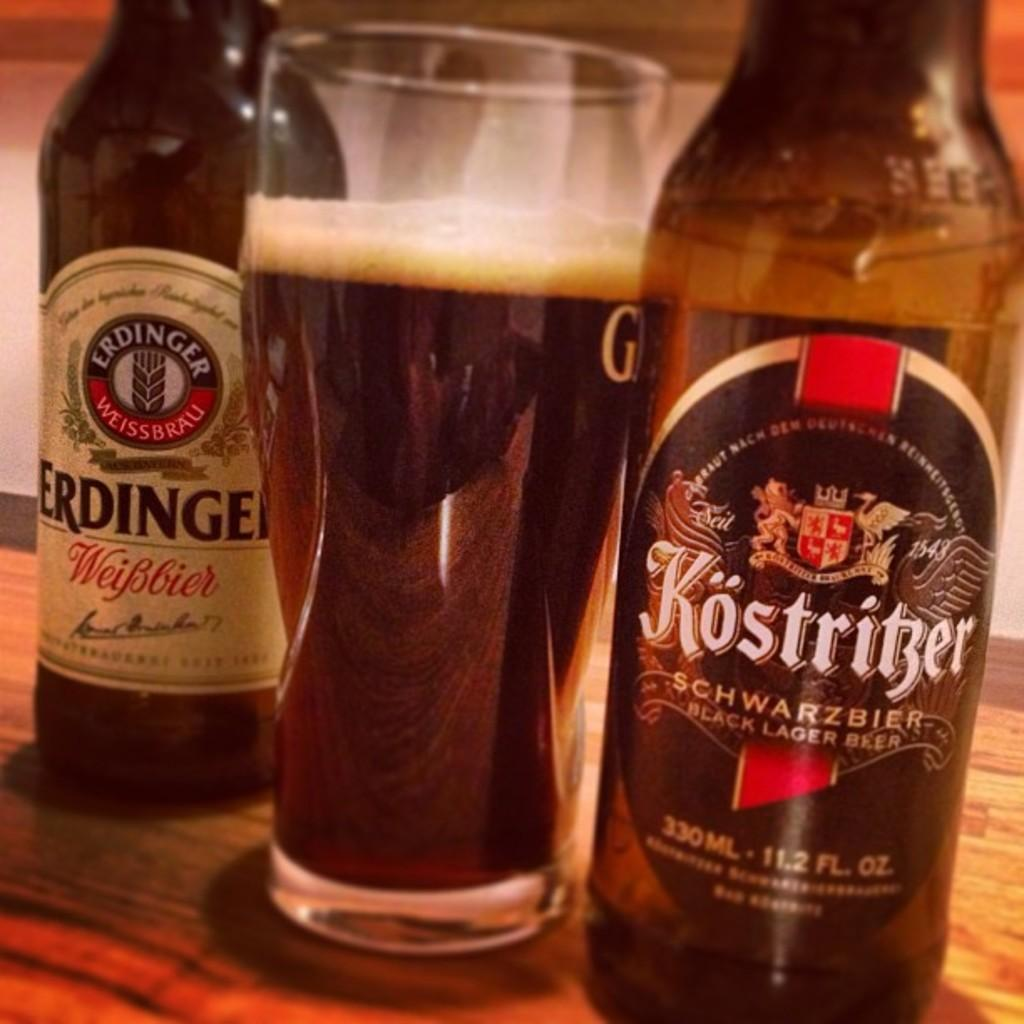<image>
Give a short and clear explanation of the subsequent image. A glass of beer with two bottles next to it, one labeled Erdinger, and one labeled Kostritzer. 